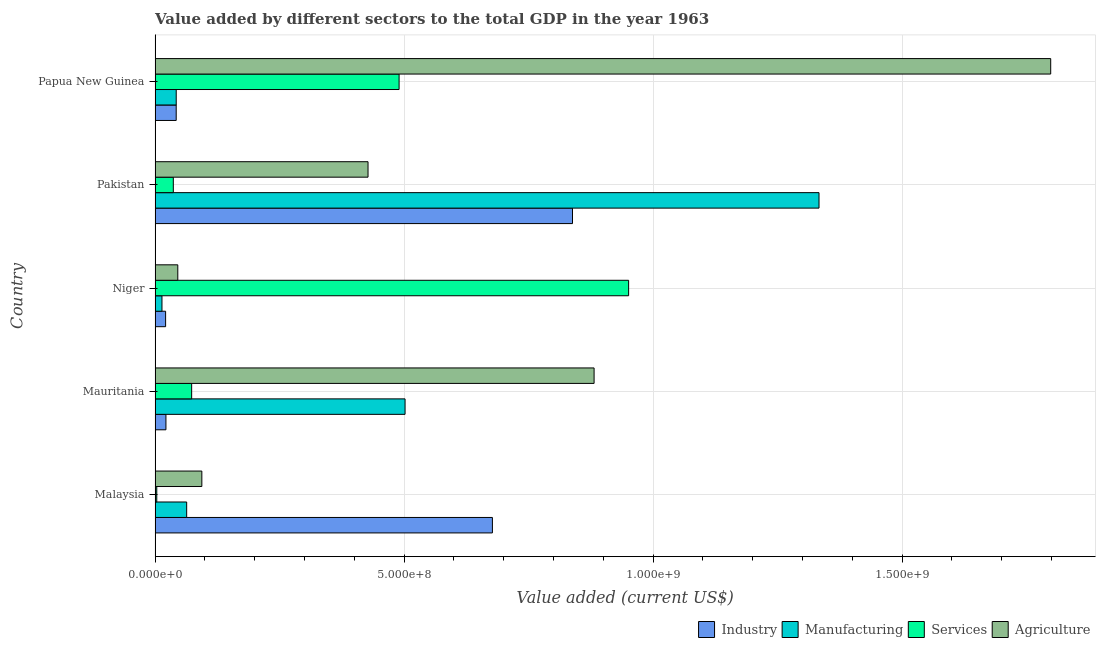How many groups of bars are there?
Offer a very short reply. 5. Are the number of bars on each tick of the Y-axis equal?
Provide a short and direct response. Yes. What is the label of the 3rd group of bars from the top?
Provide a succinct answer. Niger. What is the value added by industrial sector in Niger?
Give a very brief answer. 2.12e+07. Across all countries, what is the maximum value added by services sector?
Provide a short and direct response. 9.51e+08. Across all countries, what is the minimum value added by manufacturing sector?
Keep it short and to the point. 1.39e+07. In which country was the value added by services sector maximum?
Keep it short and to the point. Niger. In which country was the value added by agricultural sector minimum?
Your answer should be very brief. Niger. What is the total value added by manufacturing sector in the graph?
Provide a succinct answer. 1.96e+09. What is the difference between the value added by agricultural sector in Niger and that in Papua New Guinea?
Ensure brevity in your answer.  -1.75e+09. What is the difference between the value added by agricultural sector in Pakistan and the value added by services sector in Mauritania?
Provide a succinct answer. 3.54e+08. What is the average value added by services sector per country?
Your response must be concise. 3.11e+08. What is the difference between the value added by agricultural sector and value added by services sector in Mauritania?
Your response must be concise. 8.08e+08. What is the ratio of the value added by agricultural sector in Malaysia to that in Niger?
Your answer should be compact. 2.06. Is the value added by manufacturing sector in Niger less than that in Papua New Guinea?
Make the answer very short. Yes. What is the difference between the highest and the second highest value added by manufacturing sector?
Your response must be concise. 8.31e+08. What is the difference between the highest and the lowest value added by services sector?
Give a very brief answer. 9.48e+08. In how many countries, is the value added by manufacturing sector greater than the average value added by manufacturing sector taken over all countries?
Offer a very short reply. 2. Is it the case that in every country, the sum of the value added by services sector and value added by industrial sector is greater than the sum of value added by manufacturing sector and value added by agricultural sector?
Make the answer very short. No. What does the 1st bar from the top in Malaysia represents?
Give a very brief answer. Agriculture. What does the 2nd bar from the bottom in Papua New Guinea represents?
Offer a very short reply. Manufacturing. How many bars are there?
Make the answer very short. 20. How many countries are there in the graph?
Your response must be concise. 5. What is the difference between two consecutive major ticks on the X-axis?
Keep it short and to the point. 5.00e+08. Are the values on the major ticks of X-axis written in scientific E-notation?
Your answer should be compact. Yes. Does the graph contain any zero values?
Keep it short and to the point. No. Does the graph contain grids?
Your answer should be compact. Yes. How many legend labels are there?
Provide a short and direct response. 4. What is the title of the graph?
Your answer should be compact. Value added by different sectors to the total GDP in the year 1963. Does "Rule based governance" appear as one of the legend labels in the graph?
Your answer should be compact. No. What is the label or title of the X-axis?
Make the answer very short. Value added (current US$). What is the label or title of the Y-axis?
Your answer should be compact. Country. What is the Value added (current US$) in Industry in Malaysia?
Give a very brief answer. 6.77e+08. What is the Value added (current US$) in Manufacturing in Malaysia?
Ensure brevity in your answer.  6.35e+07. What is the Value added (current US$) in Services in Malaysia?
Make the answer very short. 3.44e+06. What is the Value added (current US$) of Agriculture in Malaysia?
Offer a very short reply. 9.39e+07. What is the Value added (current US$) of Industry in Mauritania?
Keep it short and to the point. 2.18e+07. What is the Value added (current US$) in Manufacturing in Mauritania?
Your answer should be very brief. 5.02e+08. What is the Value added (current US$) in Services in Mauritania?
Offer a very short reply. 7.35e+07. What is the Value added (current US$) in Agriculture in Mauritania?
Keep it short and to the point. 8.82e+08. What is the Value added (current US$) of Industry in Niger?
Your answer should be very brief. 2.12e+07. What is the Value added (current US$) in Manufacturing in Niger?
Your response must be concise. 1.39e+07. What is the Value added (current US$) of Services in Niger?
Give a very brief answer. 9.51e+08. What is the Value added (current US$) of Agriculture in Niger?
Keep it short and to the point. 4.57e+07. What is the Value added (current US$) of Industry in Pakistan?
Provide a succinct answer. 8.38e+08. What is the Value added (current US$) of Manufacturing in Pakistan?
Provide a succinct answer. 1.33e+09. What is the Value added (current US$) of Services in Pakistan?
Ensure brevity in your answer.  3.67e+07. What is the Value added (current US$) in Agriculture in Pakistan?
Your answer should be very brief. 4.28e+08. What is the Value added (current US$) in Industry in Papua New Guinea?
Provide a succinct answer. 4.24e+07. What is the Value added (current US$) of Manufacturing in Papua New Guinea?
Provide a short and direct response. 4.25e+07. What is the Value added (current US$) in Services in Papua New Guinea?
Ensure brevity in your answer.  4.90e+08. What is the Value added (current US$) of Agriculture in Papua New Guinea?
Offer a very short reply. 1.80e+09. Across all countries, what is the maximum Value added (current US$) in Industry?
Give a very brief answer. 8.38e+08. Across all countries, what is the maximum Value added (current US$) of Manufacturing?
Your response must be concise. 1.33e+09. Across all countries, what is the maximum Value added (current US$) in Services?
Your answer should be compact. 9.51e+08. Across all countries, what is the maximum Value added (current US$) of Agriculture?
Keep it short and to the point. 1.80e+09. Across all countries, what is the minimum Value added (current US$) of Industry?
Your answer should be very brief. 2.12e+07. Across all countries, what is the minimum Value added (current US$) in Manufacturing?
Make the answer very short. 1.39e+07. Across all countries, what is the minimum Value added (current US$) of Services?
Your answer should be compact. 3.44e+06. Across all countries, what is the minimum Value added (current US$) of Agriculture?
Provide a succinct answer. 4.57e+07. What is the total Value added (current US$) of Industry in the graph?
Provide a short and direct response. 1.60e+09. What is the total Value added (current US$) in Manufacturing in the graph?
Make the answer very short. 1.96e+09. What is the total Value added (current US$) of Services in the graph?
Provide a succinct answer. 1.55e+09. What is the total Value added (current US$) of Agriculture in the graph?
Provide a succinct answer. 3.25e+09. What is the difference between the Value added (current US$) in Industry in Malaysia and that in Mauritania?
Ensure brevity in your answer.  6.56e+08. What is the difference between the Value added (current US$) in Manufacturing in Malaysia and that in Mauritania?
Offer a terse response. -4.39e+08. What is the difference between the Value added (current US$) in Services in Malaysia and that in Mauritania?
Your answer should be compact. -7.01e+07. What is the difference between the Value added (current US$) of Agriculture in Malaysia and that in Mauritania?
Offer a very short reply. -7.88e+08. What is the difference between the Value added (current US$) of Industry in Malaysia and that in Niger?
Make the answer very short. 6.56e+08. What is the difference between the Value added (current US$) of Manufacturing in Malaysia and that in Niger?
Ensure brevity in your answer.  4.96e+07. What is the difference between the Value added (current US$) in Services in Malaysia and that in Niger?
Your response must be concise. -9.48e+08. What is the difference between the Value added (current US$) in Agriculture in Malaysia and that in Niger?
Keep it short and to the point. 4.83e+07. What is the difference between the Value added (current US$) in Industry in Malaysia and that in Pakistan?
Offer a very short reply. -1.61e+08. What is the difference between the Value added (current US$) of Manufacturing in Malaysia and that in Pakistan?
Keep it short and to the point. -1.27e+09. What is the difference between the Value added (current US$) in Services in Malaysia and that in Pakistan?
Keep it short and to the point. -3.32e+07. What is the difference between the Value added (current US$) of Agriculture in Malaysia and that in Pakistan?
Provide a succinct answer. -3.34e+08. What is the difference between the Value added (current US$) of Industry in Malaysia and that in Papua New Guinea?
Your response must be concise. 6.35e+08. What is the difference between the Value added (current US$) in Manufacturing in Malaysia and that in Papua New Guinea?
Your answer should be compact. 2.10e+07. What is the difference between the Value added (current US$) in Services in Malaysia and that in Papua New Guinea?
Offer a terse response. -4.87e+08. What is the difference between the Value added (current US$) in Agriculture in Malaysia and that in Papua New Guinea?
Make the answer very short. -1.70e+09. What is the difference between the Value added (current US$) of Industry in Mauritania and that in Niger?
Make the answer very short. 6.57e+05. What is the difference between the Value added (current US$) of Manufacturing in Mauritania and that in Niger?
Ensure brevity in your answer.  4.88e+08. What is the difference between the Value added (current US$) in Services in Mauritania and that in Niger?
Provide a succinct answer. -8.78e+08. What is the difference between the Value added (current US$) of Agriculture in Mauritania and that in Niger?
Your answer should be compact. 8.36e+08. What is the difference between the Value added (current US$) in Industry in Mauritania and that in Pakistan?
Offer a very short reply. -8.16e+08. What is the difference between the Value added (current US$) of Manufacturing in Mauritania and that in Pakistan?
Your response must be concise. -8.31e+08. What is the difference between the Value added (current US$) in Services in Mauritania and that in Pakistan?
Your answer should be very brief. 3.68e+07. What is the difference between the Value added (current US$) in Agriculture in Mauritania and that in Pakistan?
Ensure brevity in your answer.  4.54e+08. What is the difference between the Value added (current US$) of Industry in Mauritania and that in Papua New Guinea?
Provide a short and direct response. -2.06e+07. What is the difference between the Value added (current US$) of Manufacturing in Mauritania and that in Papua New Guinea?
Your response must be concise. 4.60e+08. What is the difference between the Value added (current US$) of Services in Mauritania and that in Papua New Guinea?
Your response must be concise. -4.17e+08. What is the difference between the Value added (current US$) of Agriculture in Mauritania and that in Papua New Guinea?
Ensure brevity in your answer.  -9.17e+08. What is the difference between the Value added (current US$) of Industry in Niger and that in Pakistan?
Your answer should be very brief. -8.17e+08. What is the difference between the Value added (current US$) in Manufacturing in Niger and that in Pakistan?
Your response must be concise. -1.32e+09. What is the difference between the Value added (current US$) in Services in Niger and that in Pakistan?
Ensure brevity in your answer.  9.14e+08. What is the difference between the Value added (current US$) in Agriculture in Niger and that in Pakistan?
Your answer should be compact. -3.82e+08. What is the difference between the Value added (current US$) in Industry in Niger and that in Papua New Guinea?
Make the answer very short. -2.13e+07. What is the difference between the Value added (current US$) in Manufacturing in Niger and that in Papua New Guinea?
Your answer should be compact. -2.86e+07. What is the difference between the Value added (current US$) in Services in Niger and that in Papua New Guinea?
Provide a short and direct response. 4.61e+08. What is the difference between the Value added (current US$) of Agriculture in Niger and that in Papua New Guinea?
Your answer should be very brief. -1.75e+09. What is the difference between the Value added (current US$) of Industry in Pakistan and that in Papua New Guinea?
Make the answer very short. 7.96e+08. What is the difference between the Value added (current US$) of Manufacturing in Pakistan and that in Papua New Guinea?
Your answer should be compact. 1.29e+09. What is the difference between the Value added (current US$) in Services in Pakistan and that in Papua New Guinea?
Your response must be concise. -4.53e+08. What is the difference between the Value added (current US$) in Agriculture in Pakistan and that in Papua New Guinea?
Ensure brevity in your answer.  -1.37e+09. What is the difference between the Value added (current US$) in Industry in Malaysia and the Value added (current US$) in Manufacturing in Mauritania?
Your response must be concise. 1.75e+08. What is the difference between the Value added (current US$) in Industry in Malaysia and the Value added (current US$) in Services in Mauritania?
Provide a succinct answer. 6.04e+08. What is the difference between the Value added (current US$) in Industry in Malaysia and the Value added (current US$) in Agriculture in Mauritania?
Ensure brevity in your answer.  -2.04e+08. What is the difference between the Value added (current US$) of Manufacturing in Malaysia and the Value added (current US$) of Services in Mauritania?
Your answer should be very brief. -1.00e+07. What is the difference between the Value added (current US$) in Manufacturing in Malaysia and the Value added (current US$) in Agriculture in Mauritania?
Provide a short and direct response. -8.18e+08. What is the difference between the Value added (current US$) in Services in Malaysia and the Value added (current US$) in Agriculture in Mauritania?
Make the answer very short. -8.78e+08. What is the difference between the Value added (current US$) of Industry in Malaysia and the Value added (current US$) of Manufacturing in Niger?
Your answer should be compact. 6.64e+08. What is the difference between the Value added (current US$) of Industry in Malaysia and the Value added (current US$) of Services in Niger?
Your answer should be very brief. -2.74e+08. What is the difference between the Value added (current US$) in Industry in Malaysia and the Value added (current US$) in Agriculture in Niger?
Your answer should be very brief. 6.32e+08. What is the difference between the Value added (current US$) in Manufacturing in Malaysia and the Value added (current US$) in Services in Niger?
Your answer should be compact. -8.88e+08. What is the difference between the Value added (current US$) of Manufacturing in Malaysia and the Value added (current US$) of Agriculture in Niger?
Offer a terse response. 1.78e+07. What is the difference between the Value added (current US$) of Services in Malaysia and the Value added (current US$) of Agriculture in Niger?
Provide a short and direct response. -4.22e+07. What is the difference between the Value added (current US$) of Industry in Malaysia and the Value added (current US$) of Manufacturing in Pakistan?
Provide a succinct answer. -6.56e+08. What is the difference between the Value added (current US$) of Industry in Malaysia and the Value added (current US$) of Services in Pakistan?
Provide a succinct answer. 6.41e+08. What is the difference between the Value added (current US$) in Industry in Malaysia and the Value added (current US$) in Agriculture in Pakistan?
Offer a very short reply. 2.50e+08. What is the difference between the Value added (current US$) of Manufacturing in Malaysia and the Value added (current US$) of Services in Pakistan?
Provide a short and direct response. 2.68e+07. What is the difference between the Value added (current US$) of Manufacturing in Malaysia and the Value added (current US$) of Agriculture in Pakistan?
Ensure brevity in your answer.  -3.64e+08. What is the difference between the Value added (current US$) of Services in Malaysia and the Value added (current US$) of Agriculture in Pakistan?
Your answer should be very brief. -4.24e+08. What is the difference between the Value added (current US$) of Industry in Malaysia and the Value added (current US$) of Manufacturing in Papua New Guinea?
Keep it short and to the point. 6.35e+08. What is the difference between the Value added (current US$) of Industry in Malaysia and the Value added (current US$) of Services in Papua New Guinea?
Offer a very short reply. 1.87e+08. What is the difference between the Value added (current US$) in Industry in Malaysia and the Value added (current US$) in Agriculture in Papua New Guinea?
Give a very brief answer. -1.12e+09. What is the difference between the Value added (current US$) of Manufacturing in Malaysia and the Value added (current US$) of Services in Papua New Guinea?
Provide a short and direct response. -4.27e+08. What is the difference between the Value added (current US$) of Manufacturing in Malaysia and the Value added (current US$) of Agriculture in Papua New Guinea?
Your answer should be compact. -1.74e+09. What is the difference between the Value added (current US$) of Services in Malaysia and the Value added (current US$) of Agriculture in Papua New Guinea?
Make the answer very short. -1.80e+09. What is the difference between the Value added (current US$) of Industry in Mauritania and the Value added (current US$) of Manufacturing in Niger?
Make the answer very short. 7.97e+06. What is the difference between the Value added (current US$) of Industry in Mauritania and the Value added (current US$) of Services in Niger?
Offer a very short reply. -9.29e+08. What is the difference between the Value added (current US$) in Industry in Mauritania and the Value added (current US$) in Agriculture in Niger?
Provide a short and direct response. -2.38e+07. What is the difference between the Value added (current US$) in Manufacturing in Mauritania and the Value added (current US$) in Services in Niger?
Give a very brief answer. -4.49e+08. What is the difference between the Value added (current US$) of Manufacturing in Mauritania and the Value added (current US$) of Agriculture in Niger?
Keep it short and to the point. 4.56e+08. What is the difference between the Value added (current US$) of Services in Mauritania and the Value added (current US$) of Agriculture in Niger?
Ensure brevity in your answer.  2.78e+07. What is the difference between the Value added (current US$) in Industry in Mauritania and the Value added (current US$) in Manufacturing in Pakistan?
Give a very brief answer. -1.31e+09. What is the difference between the Value added (current US$) of Industry in Mauritania and the Value added (current US$) of Services in Pakistan?
Provide a succinct answer. -1.48e+07. What is the difference between the Value added (current US$) in Industry in Mauritania and the Value added (current US$) in Agriculture in Pakistan?
Offer a terse response. -4.06e+08. What is the difference between the Value added (current US$) in Manufacturing in Mauritania and the Value added (current US$) in Services in Pakistan?
Provide a succinct answer. 4.65e+08. What is the difference between the Value added (current US$) of Manufacturing in Mauritania and the Value added (current US$) of Agriculture in Pakistan?
Offer a terse response. 7.44e+07. What is the difference between the Value added (current US$) in Services in Mauritania and the Value added (current US$) in Agriculture in Pakistan?
Your response must be concise. -3.54e+08. What is the difference between the Value added (current US$) of Industry in Mauritania and the Value added (current US$) of Manufacturing in Papua New Guinea?
Give a very brief answer. -2.07e+07. What is the difference between the Value added (current US$) in Industry in Mauritania and the Value added (current US$) in Services in Papua New Guinea?
Your answer should be compact. -4.68e+08. What is the difference between the Value added (current US$) in Industry in Mauritania and the Value added (current US$) in Agriculture in Papua New Guinea?
Keep it short and to the point. -1.78e+09. What is the difference between the Value added (current US$) in Manufacturing in Mauritania and the Value added (current US$) in Services in Papua New Guinea?
Ensure brevity in your answer.  1.20e+07. What is the difference between the Value added (current US$) of Manufacturing in Mauritania and the Value added (current US$) of Agriculture in Papua New Guinea?
Give a very brief answer. -1.30e+09. What is the difference between the Value added (current US$) of Services in Mauritania and the Value added (current US$) of Agriculture in Papua New Guinea?
Give a very brief answer. -1.73e+09. What is the difference between the Value added (current US$) in Industry in Niger and the Value added (current US$) in Manufacturing in Pakistan?
Offer a terse response. -1.31e+09. What is the difference between the Value added (current US$) in Industry in Niger and the Value added (current US$) in Services in Pakistan?
Keep it short and to the point. -1.55e+07. What is the difference between the Value added (current US$) in Industry in Niger and the Value added (current US$) in Agriculture in Pakistan?
Your response must be concise. -4.07e+08. What is the difference between the Value added (current US$) in Manufacturing in Niger and the Value added (current US$) in Services in Pakistan?
Ensure brevity in your answer.  -2.28e+07. What is the difference between the Value added (current US$) in Manufacturing in Niger and the Value added (current US$) in Agriculture in Pakistan?
Offer a terse response. -4.14e+08. What is the difference between the Value added (current US$) in Services in Niger and the Value added (current US$) in Agriculture in Pakistan?
Your answer should be very brief. 5.23e+08. What is the difference between the Value added (current US$) in Industry in Niger and the Value added (current US$) in Manufacturing in Papua New Guinea?
Your answer should be very brief. -2.13e+07. What is the difference between the Value added (current US$) in Industry in Niger and the Value added (current US$) in Services in Papua New Guinea?
Provide a short and direct response. -4.69e+08. What is the difference between the Value added (current US$) in Industry in Niger and the Value added (current US$) in Agriculture in Papua New Guinea?
Offer a very short reply. -1.78e+09. What is the difference between the Value added (current US$) of Manufacturing in Niger and the Value added (current US$) of Services in Papua New Guinea?
Offer a terse response. -4.76e+08. What is the difference between the Value added (current US$) in Manufacturing in Niger and the Value added (current US$) in Agriculture in Papua New Guinea?
Offer a terse response. -1.78e+09. What is the difference between the Value added (current US$) of Services in Niger and the Value added (current US$) of Agriculture in Papua New Guinea?
Keep it short and to the point. -8.48e+08. What is the difference between the Value added (current US$) of Industry in Pakistan and the Value added (current US$) of Manufacturing in Papua New Guinea?
Ensure brevity in your answer.  7.96e+08. What is the difference between the Value added (current US$) in Industry in Pakistan and the Value added (current US$) in Services in Papua New Guinea?
Ensure brevity in your answer.  3.48e+08. What is the difference between the Value added (current US$) of Industry in Pakistan and the Value added (current US$) of Agriculture in Papua New Guinea?
Your response must be concise. -9.60e+08. What is the difference between the Value added (current US$) of Manufacturing in Pakistan and the Value added (current US$) of Services in Papua New Guinea?
Your answer should be very brief. 8.43e+08. What is the difference between the Value added (current US$) of Manufacturing in Pakistan and the Value added (current US$) of Agriculture in Papua New Guinea?
Give a very brief answer. -4.65e+08. What is the difference between the Value added (current US$) in Services in Pakistan and the Value added (current US$) in Agriculture in Papua New Guinea?
Your response must be concise. -1.76e+09. What is the average Value added (current US$) of Industry per country?
Offer a terse response. 3.20e+08. What is the average Value added (current US$) of Manufacturing per country?
Your answer should be compact. 3.91e+08. What is the average Value added (current US$) of Services per country?
Keep it short and to the point. 3.11e+08. What is the average Value added (current US$) in Agriculture per country?
Keep it short and to the point. 6.50e+08. What is the difference between the Value added (current US$) of Industry and Value added (current US$) of Manufacturing in Malaysia?
Offer a very short reply. 6.14e+08. What is the difference between the Value added (current US$) of Industry and Value added (current US$) of Services in Malaysia?
Your answer should be compact. 6.74e+08. What is the difference between the Value added (current US$) of Industry and Value added (current US$) of Agriculture in Malaysia?
Your answer should be very brief. 5.84e+08. What is the difference between the Value added (current US$) in Manufacturing and Value added (current US$) in Services in Malaysia?
Make the answer very short. 6.00e+07. What is the difference between the Value added (current US$) in Manufacturing and Value added (current US$) in Agriculture in Malaysia?
Keep it short and to the point. -3.05e+07. What is the difference between the Value added (current US$) of Services and Value added (current US$) of Agriculture in Malaysia?
Keep it short and to the point. -9.05e+07. What is the difference between the Value added (current US$) in Industry and Value added (current US$) in Manufacturing in Mauritania?
Provide a succinct answer. -4.80e+08. What is the difference between the Value added (current US$) of Industry and Value added (current US$) of Services in Mauritania?
Your answer should be very brief. -5.17e+07. What is the difference between the Value added (current US$) in Industry and Value added (current US$) in Agriculture in Mauritania?
Give a very brief answer. -8.60e+08. What is the difference between the Value added (current US$) of Manufacturing and Value added (current US$) of Services in Mauritania?
Your answer should be compact. 4.29e+08. What is the difference between the Value added (current US$) in Manufacturing and Value added (current US$) in Agriculture in Mauritania?
Provide a short and direct response. -3.80e+08. What is the difference between the Value added (current US$) in Services and Value added (current US$) in Agriculture in Mauritania?
Ensure brevity in your answer.  -8.08e+08. What is the difference between the Value added (current US$) in Industry and Value added (current US$) in Manufacturing in Niger?
Your answer should be very brief. 7.31e+06. What is the difference between the Value added (current US$) of Industry and Value added (current US$) of Services in Niger?
Your answer should be very brief. -9.30e+08. What is the difference between the Value added (current US$) in Industry and Value added (current US$) in Agriculture in Niger?
Offer a terse response. -2.45e+07. What is the difference between the Value added (current US$) of Manufacturing and Value added (current US$) of Services in Niger?
Your answer should be very brief. -9.37e+08. What is the difference between the Value added (current US$) in Manufacturing and Value added (current US$) in Agriculture in Niger?
Offer a very short reply. -3.18e+07. What is the difference between the Value added (current US$) in Services and Value added (current US$) in Agriculture in Niger?
Give a very brief answer. 9.05e+08. What is the difference between the Value added (current US$) in Industry and Value added (current US$) in Manufacturing in Pakistan?
Offer a terse response. -4.95e+08. What is the difference between the Value added (current US$) in Industry and Value added (current US$) in Services in Pakistan?
Make the answer very short. 8.02e+08. What is the difference between the Value added (current US$) in Industry and Value added (current US$) in Agriculture in Pakistan?
Ensure brevity in your answer.  4.11e+08. What is the difference between the Value added (current US$) in Manufacturing and Value added (current US$) in Services in Pakistan?
Keep it short and to the point. 1.30e+09. What is the difference between the Value added (current US$) of Manufacturing and Value added (current US$) of Agriculture in Pakistan?
Make the answer very short. 9.06e+08. What is the difference between the Value added (current US$) of Services and Value added (current US$) of Agriculture in Pakistan?
Give a very brief answer. -3.91e+08. What is the difference between the Value added (current US$) of Industry and Value added (current US$) of Manufacturing in Papua New Guinea?
Provide a succinct answer. -5.74e+04. What is the difference between the Value added (current US$) in Industry and Value added (current US$) in Services in Papua New Guinea?
Ensure brevity in your answer.  -4.48e+08. What is the difference between the Value added (current US$) in Industry and Value added (current US$) in Agriculture in Papua New Guinea?
Give a very brief answer. -1.76e+09. What is the difference between the Value added (current US$) of Manufacturing and Value added (current US$) of Services in Papua New Guinea?
Ensure brevity in your answer.  -4.48e+08. What is the difference between the Value added (current US$) in Manufacturing and Value added (current US$) in Agriculture in Papua New Guinea?
Provide a succinct answer. -1.76e+09. What is the difference between the Value added (current US$) of Services and Value added (current US$) of Agriculture in Papua New Guinea?
Your answer should be compact. -1.31e+09. What is the ratio of the Value added (current US$) of Industry in Malaysia to that in Mauritania?
Ensure brevity in your answer.  31.01. What is the ratio of the Value added (current US$) in Manufacturing in Malaysia to that in Mauritania?
Offer a terse response. 0.13. What is the ratio of the Value added (current US$) in Services in Malaysia to that in Mauritania?
Provide a succinct answer. 0.05. What is the ratio of the Value added (current US$) in Agriculture in Malaysia to that in Mauritania?
Offer a terse response. 0.11. What is the ratio of the Value added (current US$) in Industry in Malaysia to that in Niger?
Your answer should be compact. 31.98. What is the ratio of the Value added (current US$) in Manufacturing in Malaysia to that in Niger?
Your answer should be compact. 4.57. What is the ratio of the Value added (current US$) in Services in Malaysia to that in Niger?
Give a very brief answer. 0. What is the ratio of the Value added (current US$) in Agriculture in Malaysia to that in Niger?
Your answer should be very brief. 2.06. What is the ratio of the Value added (current US$) of Industry in Malaysia to that in Pakistan?
Make the answer very short. 0.81. What is the ratio of the Value added (current US$) of Manufacturing in Malaysia to that in Pakistan?
Your answer should be compact. 0.05. What is the ratio of the Value added (current US$) of Services in Malaysia to that in Pakistan?
Your answer should be very brief. 0.09. What is the ratio of the Value added (current US$) in Agriculture in Malaysia to that in Pakistan?
Your response must be concise. 0.22. What is the ratio of the Value added (current US$) in Industry in Malaysia to that in Papua New Guinea?
Offer a very short reply. 15.96. What is the ratio of the Value added (current US$) of Manufacturing in Malaysia to that in Papua New Guinea?
Provide a short and direct response. 1.49. What is the ratio of the Value added (current US$) of Services in Malaysia to that in Papua New Guinea?
Make the answer very short. 0.01. What is the ratio of the Value added (current US$) of Agriculture in Malaysia to that in Papua New Guinea?
Make the answer very short. 0.05. What is the ratio of the Value added (current US$) in Industry in Mauritania to that in Niger?
Offer a very short reply. 1.03. What is the ratio of the Value added (current US$) of Manufacturing in Mauritania to that in Niger?
Make the answer very short. 36.18. What is the ratio of the Value added (current US$) of Services in Mauritania to that in Niger?
Give a very brief answer. 0.08. What is the ratio of the Value added (current US$) in Agriculture in Mauritania to that in Niger?
Provide a succinct answer. 19.31. What is the ratio of the Value added (current US$) of Industry in Mauritania to that in Pakistan?
Your answer should be compact. 0.03. What is the ratio of the Value added (current US$) of Manufacturing in Mauritania to that in Pakistan?
Make the answer very short. 0.38. What is the ratio of the Value added (current US$) in Services in Mauritania to that in Pakistan?
Provide a succinct answer. 2.01. What is the ratio of the Value added (current US$) in Agriculture in Mauritania to that in Pakistan?
Ensure brevity in your answer.  2.06. What is the ratio of the Value added (current US$) of Industry in Mauritania to that in Papua New Guinea?
Your answer should be compact. 0.51. What is the ratio of the Value added (current US$) in Manufacturing in Mauritania to that in Papua New Guinea?
Provide a short and direct response. 11.81. What is the ratio of the Value added (current US$) of Services in Mauritania to that in Papua New Guinea?
Ensure brevity in your answer.  0.15. What is the ratio of the Value added (current US$) of Agriculture in Mauritania to that in Papua New Guinea?
Provide a short and direct response. 0.49. What is the ratio of the Value added (current US$) in Industry in Niger to that in Pakistan?
Your answer should be very brief. 0.03. What is the ratio of the Value added (current US$) of Manufacturing in Niger to that in Pakistan?
Your response must be concise. 0.01. What is the ratio of the Value added (current US$) in Services in Niger to that in Pakistan?
Your answer should be very brief. 25.94. What is the ratio of the Value added (current US$) of Agriculture in Niger to that in Pakistan?
Provide a short and direct response. 0.11. What is the ratio of the Value added (current US$) of Industry in Niger to that in Papua New Guinea?
Provide a succinct answer. 0.5. What is the ratio of the Value added (current US$) of Manufacturing in Niger to that in Papua New Guinea?
Provide a succinct answer. 0.33. What is the ratio of the Value added (current US$) in Services in Niger to that in Papua New Guinea?
Ensure brevity in your answer.  1.94. What is the ratio of the Value added (current US$) in Agriculture in Niger to that in Papua New Guinea?
Your response must be concise. 0.03. What is the ratio of the Value added (current US$) in Industry in Pakistan to that in Papua New Guinea?
Offer a terse response. 19.75. What is the ratio of the Value added (current US$) in Manufacturing in Pakistan to that in Papua New Guinea?
Keep it short and to the point. 31.37. What is the ratio of the Value added (current US$) of Services in Pakistan to that in Papua New Guinea?
Ensure brevity in your answer.  0.07. What is the ratio of the Value added (current US$) in Agriculture in Pakistan to that in Papua New Guinea?
Your answer should be compact. 0.24. What is the difference between the highest and the second highest Value added (current US$) in Industry?
Keep it short and to the point. 1.61e+08. What is the difference between the highest and the second highest Value added (current US$) in Manufacturing?
Your response must be concise. 8.31e+08. What is the difference between the highest and the second highest Value added (current US$) of Services?
Ensure brevity in your answer.  4.61e+08. What is the difference between the highest and the second highest Value added (current US$) of Agriculture?
Your response must be concise. 9.17e+08. What is the difference between the highest and the lowest Value added (current US$) of Industry?
Ensure brevity in your answer.  8.17e+08. What is the difference between the highest and the lowest Value added (current US$) of Manufacturing?
Your answer should be very brief. 1.32e+09. What is the difference between the highest and the lowest Value added (current US$) in Services?
Make the answer very short. 9.48e+08. What is the difference between the highest and the lowest Value added (current US$) of Agriculture?
Offer a terse response. 1.75e+09. 